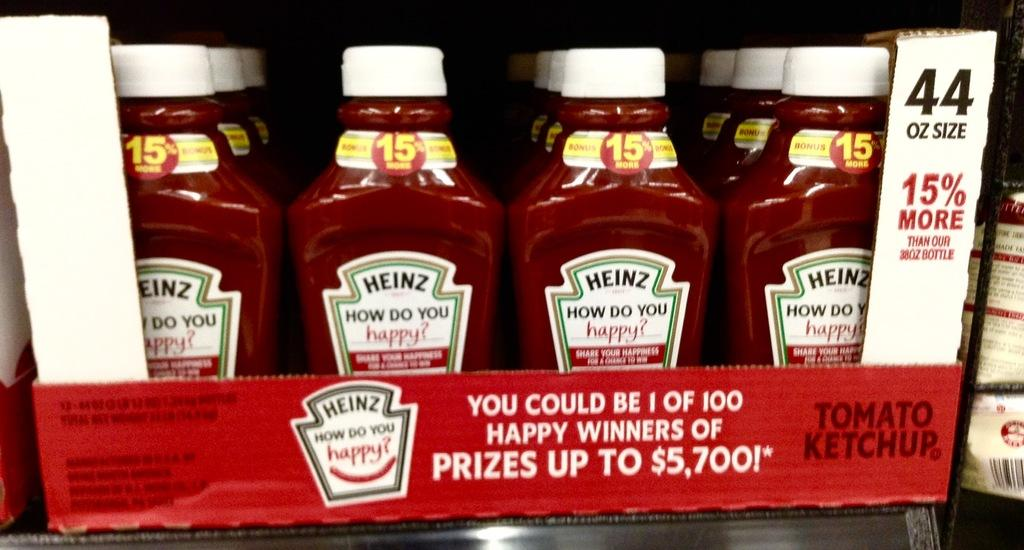What objects are present in the image? There are bottles in the image. What color are the bottles? The bottles are red. What color are the bottle caps? The bottle caps are white. How are the bottles arranged in the image? The bottles appear to be placed in a box. What type of marble is used to decorate the competition area in the image? There is no marble or competition area present in the image; it features red bottles with white caps placed in a box. 